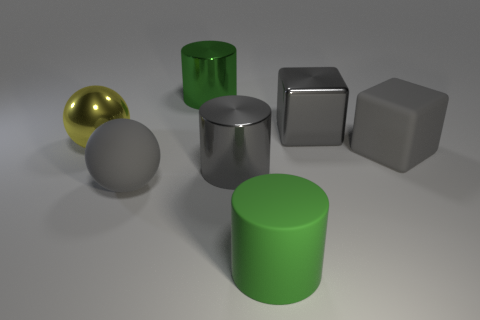Subtract all green cylinders. How many cylinders are left? 1 Add 3 small green matte things. How many objects exist? 10 Subtract all yellow spheres. How many spheres are left? 1 Subtract all blocks. How many objects are left? 5 Add 6 spheres. How many spheres are left? 8 Add 5 metallic spheres. How many metallic spheres exist? 6 Subtract 2 gray blocks. How many objects are left? 5 Subtract 1 blocks. How many blocks are left? 1 Subtract all gray balls. Subtract all cyan cylinders. How many balls are left? 1 Subtract all gray balls. How many green cylinders are left? 2 